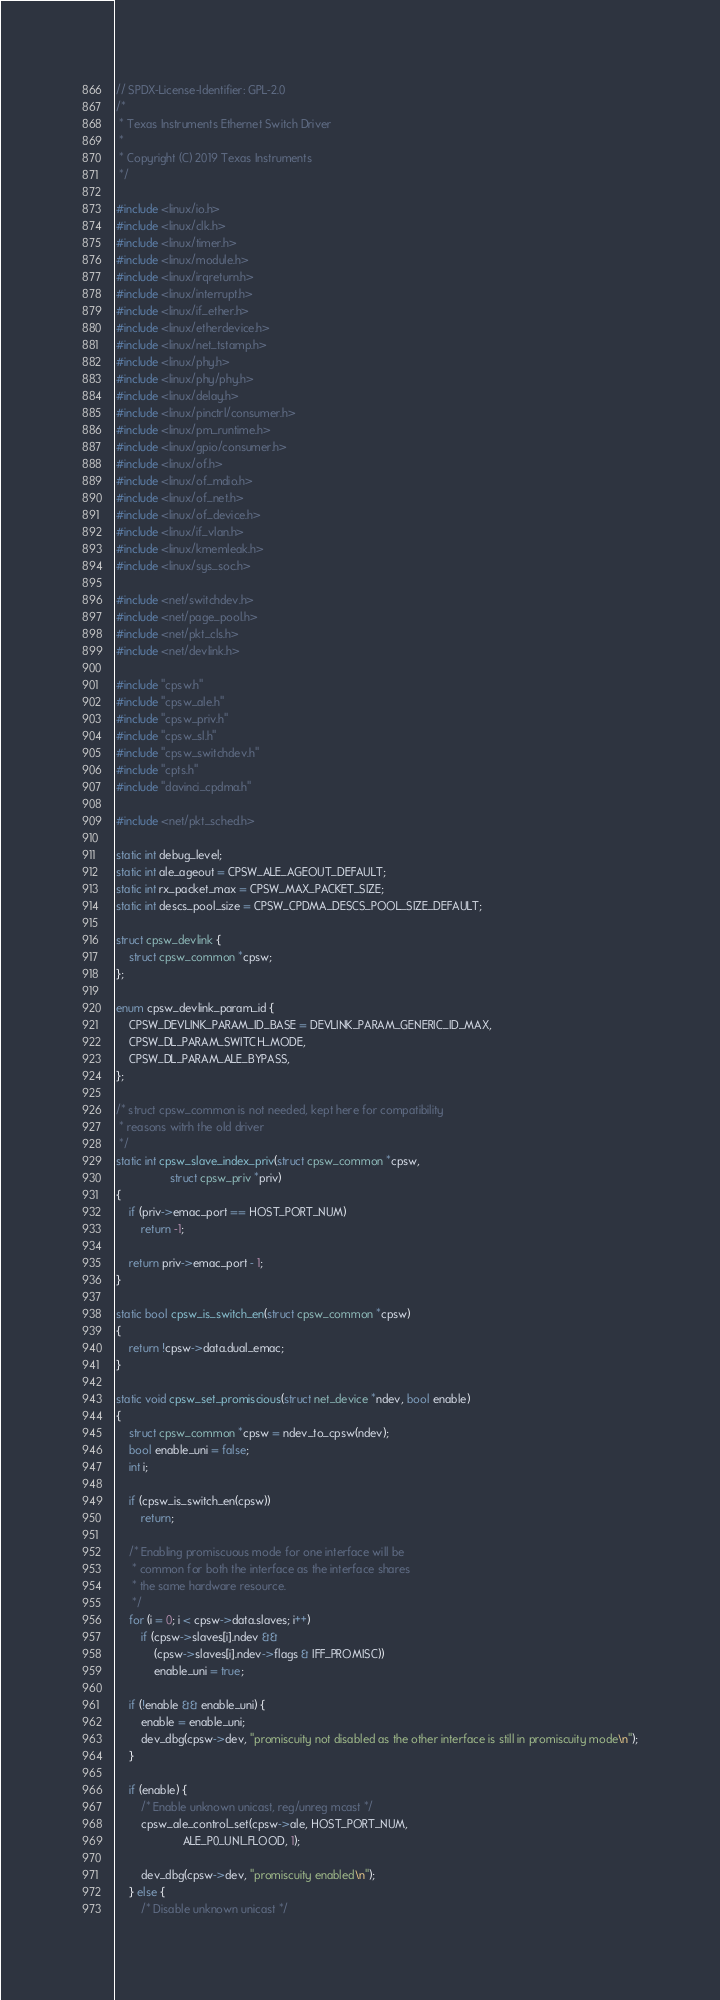<code> <loc_0><loc_0><loc_500><loc_500><_C_>// SPDX-License-Identifier: GPL-2.0
/*
 * Texas Instruments Ethernet Switch Driver
 *
 * Copyright (C) 2019 Texas Instruments
 */

#include <linux/io.h>
#include <linux/clk.h>
#include <linux/timer.h>
#include <linux/module.h>
#include <linux/irqreturn.h>
#include <linux/interrupt.h>
#include <linux/if_ether.h>
#include <linux/etherdevice.h>
#include <linux/net_tstamp.h>
#include <linux/phy.h>
#include <linux/phy/phy.h>
#include <linux/delay.h>
#include <linux/pinctrl/consumer.h>
#include <linux/pm_runtime.h>
#include <linux/gpio/consumer.h>
#include <linux/of.h>
#include <linux/of_mdio.h>
#include <linux/of_net.h>
#include <linux/of_device.h>
#include <linux/if_vlan.h>
#include <linux/kmemleak.h>
#include <linux/sys_soc.h>

#include <net/switchdev.h>
#include <net/page_pool.h>
#include <net/pkt_cls.h>
#include <net/devlink.h>

#include "cpsw.h"
#include "cpsw_ale.h"
#include "cpsw_priv.h"
#include "cpsw_sl.h"
#include "cpsw_switchdev.h"
#include "cpts.h"
#include "davinci_cpdma.h"

#include <net/pkt_sched.h>

static int debug_level;
static int ale_ageout = CPSW_ALE_AGEOUT_DEFAULT;
static int rx_packet_max = CPSW_MAX_PACKET_SIZE;
static int descs_pool_size = CPSW_CPDMA_DESCS_POOL_SIZE_DEFAULT;

struct cpsw_devlink {
	struct cpsw_common *cpsw;
};

enum cpsw_devlink_param_id {
	CPSW_DEVLINK_PARAM_ID_BASE = DEVLINK_PARAM_GENERIC_ID_MAX,
	CPSW_DL_PARAM_SWITCH_MODE,
	CPSW_DL_PARAM_ALE_BYPASS,
};

/* struct cpsw_common is not needed, kept here for compatibility
 * reasons witrh the old driver
 */
static int cpsw_slave_index_priv(struct cpsw_common *cpsw,
				 struct cpsw_priv *priv)
{
	if (priv->emac_port == HOST_PORT_NUM)
		return -1;

	return priv->emac_port - 1;
}

static bool cpsw_is_switch_en(struct cpsw_common *cpsw)
{
	return !cpsw->data.dual_emac;
}

static void cpsw_set_promiscious(struct net_device *ndev, bool enable)
{
	struct cpsw_common *cpsw = ndev_to_cpsw(ndev);
	bool enable_uni = false;
	int i;

	if (cpsw_is_switch_en(cpsw))
		return;

	/* Enabling promiscuous mode for one interface will be
	 * common for both the interface as the interface shares
	 * the same hardware resource.
	 */
	for (i = 0; i < cpsw->data.slaves; i++)
		if (cpsw->slaves[i].ndev &&
		    (cpsw->slaves[i].ndev->flags & IFF_PROMISC))
			enable_uni = true;

	if (!enable && enable_uni) {
		enable = enable_uni;
		dev_dbg(cpsw->dev, "promiscuity not disabled as the other interface is still in promiscuity mode\n");
	}

	if (enable) {
		/* Enable unknown unicast, reg/unreg mcast */
		cpsw_ale_control_set(cpsw->ale, HOST_PORT_NUM,
				     ALE_P0_UNI_FLOOD, 1);

		dev_dbg(cpsw->dev, "promiscuity enabled\n");
	} else {
		/* Disable unknown unicast */</code> 